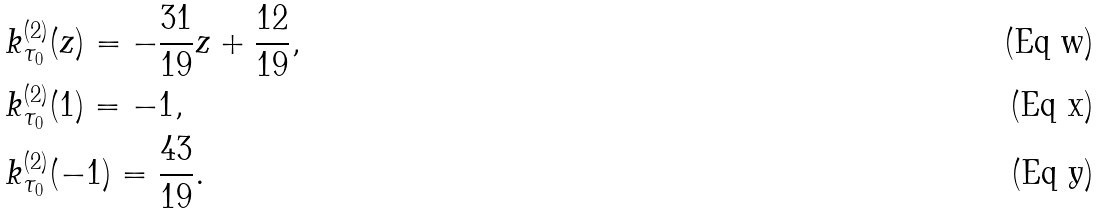Convert formula to latex. <formula><loc_0><loc_0><loc_500><loc_500>& k _ { \tau _ { 0 } } ^ { ( 2 ) } ( z ) = - \frac { 3 1 } { 1 9 } z + \frac { 1 2 } { 1 9 } , \\ & k _ { \tau _ { 0 } } ^ { ( 2 ) } ( 1 ) = - 1 , \\ & k _ { \tau _ { 0 } } ^ { ( 2 ) } ( - 1 ) = \frac { 4 3 } { 1 9 } .</formula> 